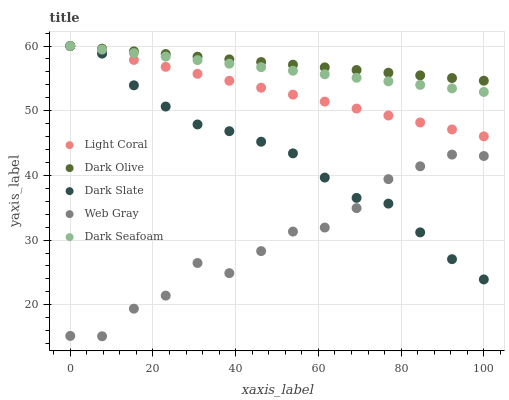Does Web Gray have the minimum area under the curve?
Answer yes or no. Yes. Does Dark Olive have the maximum area under the curve?
Answer yes or no. Yes. Does Dark Slate have the minimum area under the curve?
Answer yes or no. No. Does Dark Slate have the maximum area under the curve?
Answer yes or no. No. Is Dark Seafoam the smoothest?
Answer yes or no. Yes. Is Web Gray the roughest?
Answer yes or no. Yes. Is Dark Slate the smoothest?
Answer yes or no. No. Is Dark Slate the roughest?
Answer yes or no. No. Does Web Gray have the lowest value?
Answer yes or no. Yes. Does Dark Slate have the lowest value?
Answer yes or no. No. Does Dark Olive have the highest value?
Answer yes or no. Yes. Does Web Gray have the highest value?
Answer yes or no. No. Is Web Gray less than Dark Olive?
Answer yes or no. Yes. Is Dark Olive greater than Web Gray?
Answer yes or no. Yes. Does Web Gray intersect Dark Slate?
Answer yes or no. Yes. Is Web Gray less than Dark Slate?
Answer yes or no. No. Is Web Gray greater than Dark Slate?
Answer yes or no. No. Does Web Gray intersect Dark Olive?
Answer yes or no. No. 